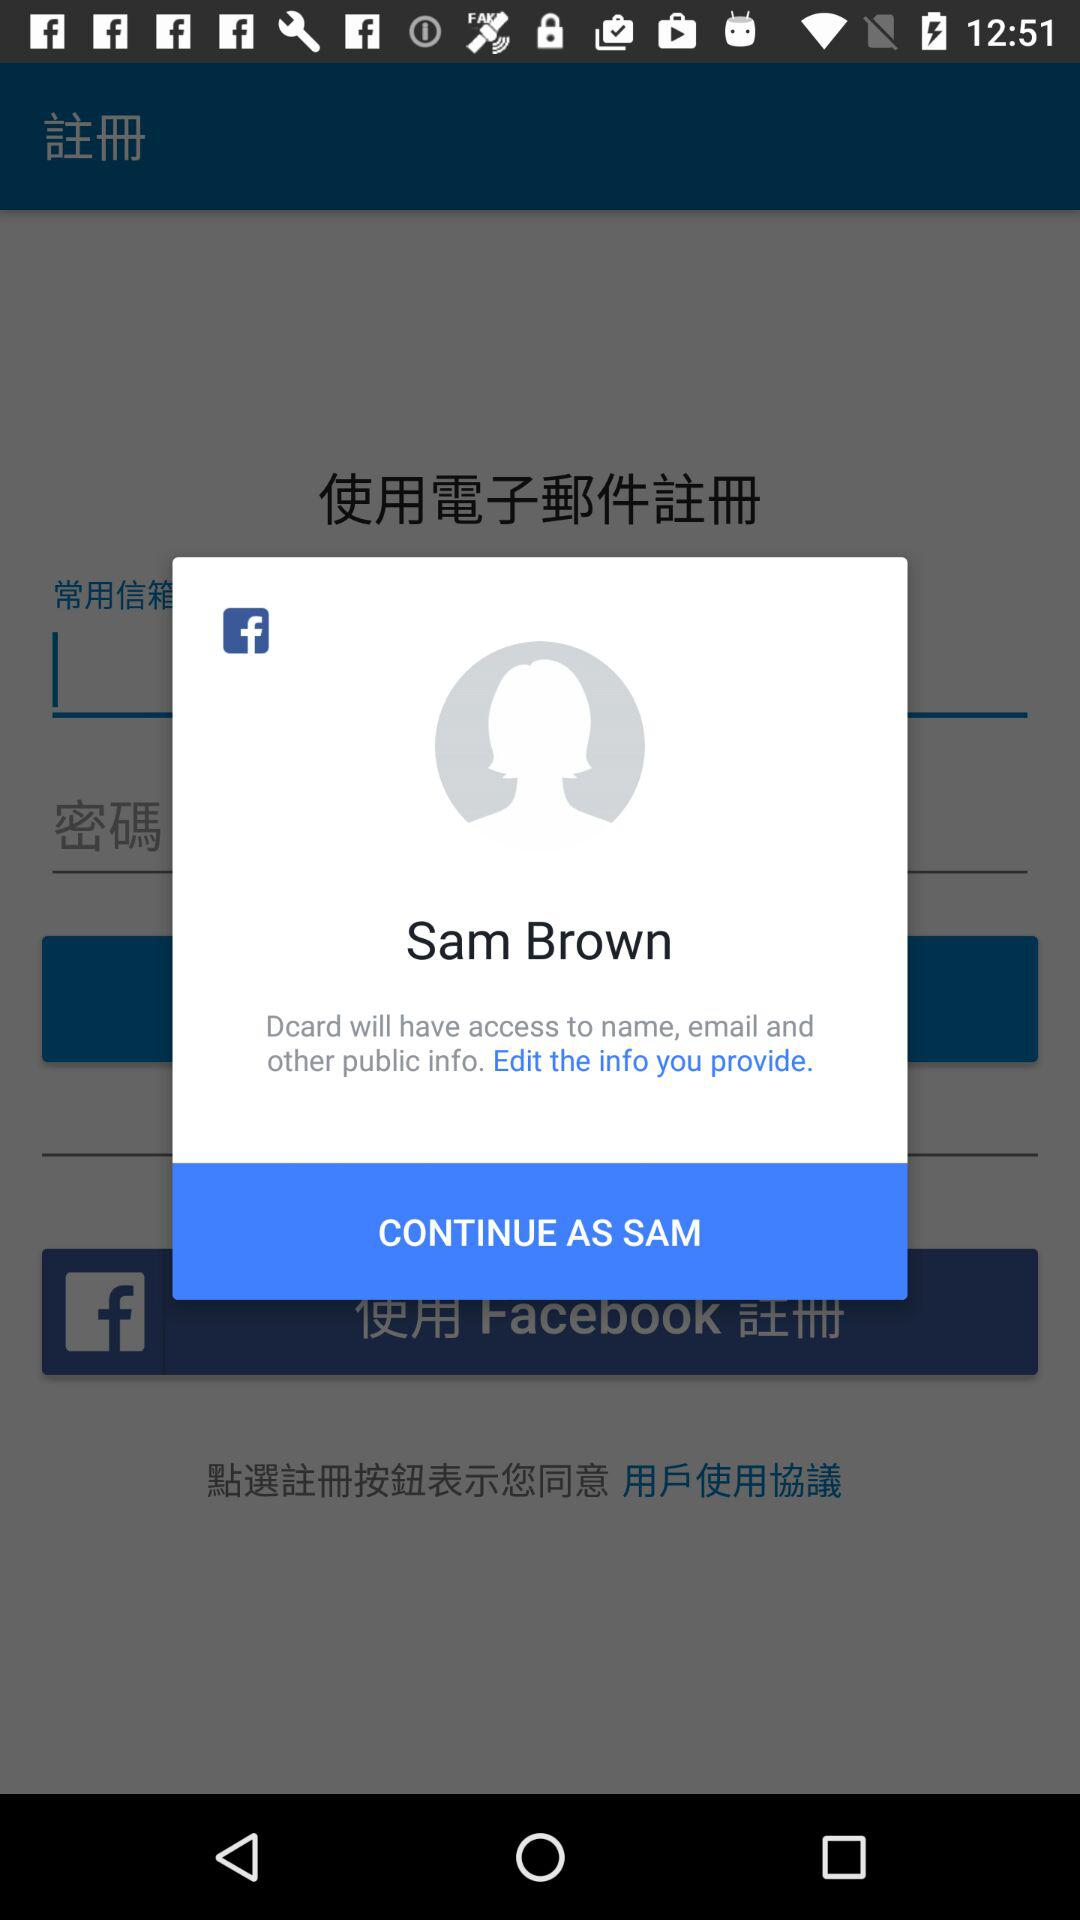When is Sam Brown granting access permissions?
When the provided information is insufficient, respond with <no answer>. <no answer> 